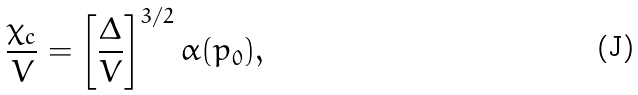Convert formula to latex. <formula><loc_0><loc_0><loc_500><loc_500>\frac { \chi _ { c } } { V } = \left [ \frac { \Delta } { V } \right ] ^ { 3 / 2 } \alpha ( p _ { 0 } ) ,</formula> 